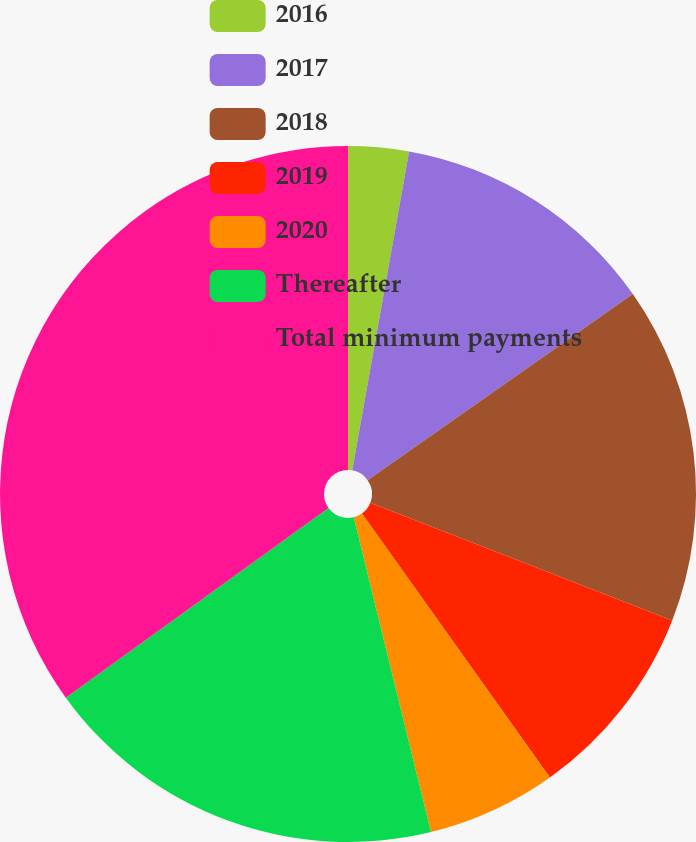Convert chart. <chart><loc_0><loc_0><loc_500><loc_500><pie_chart><fcel>2016<fcel>2017<fcel>2018<fcel>2019<fcel>2020<fcel>Thereafter<fcel>Total minimum payments<nl><fcel>2.81%<fcel>12.45%<fcel>15.66%<fcel>9.23%<fcel>6.02%<fcel>18.88%<fcel>34.95%<nl></chart> 